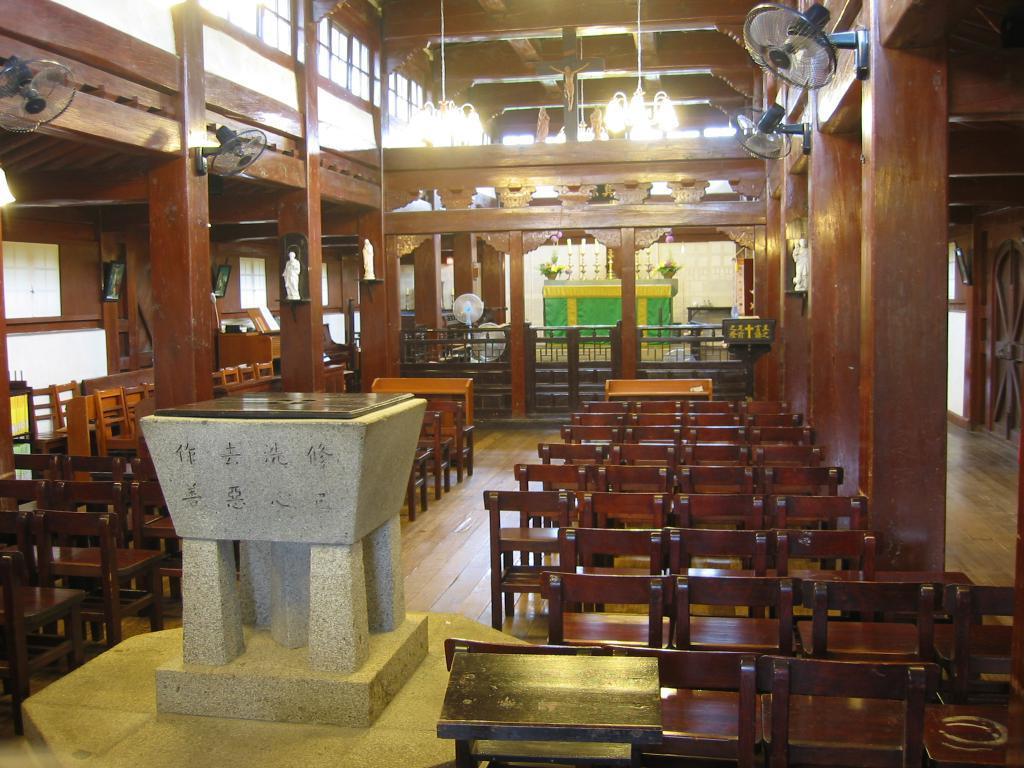Please provide a concise description of this image. In this image I see number of chairs, fans and the lights over here and I see the floor and I can also see small sculptures and I see a thing over here which is of white in color. 